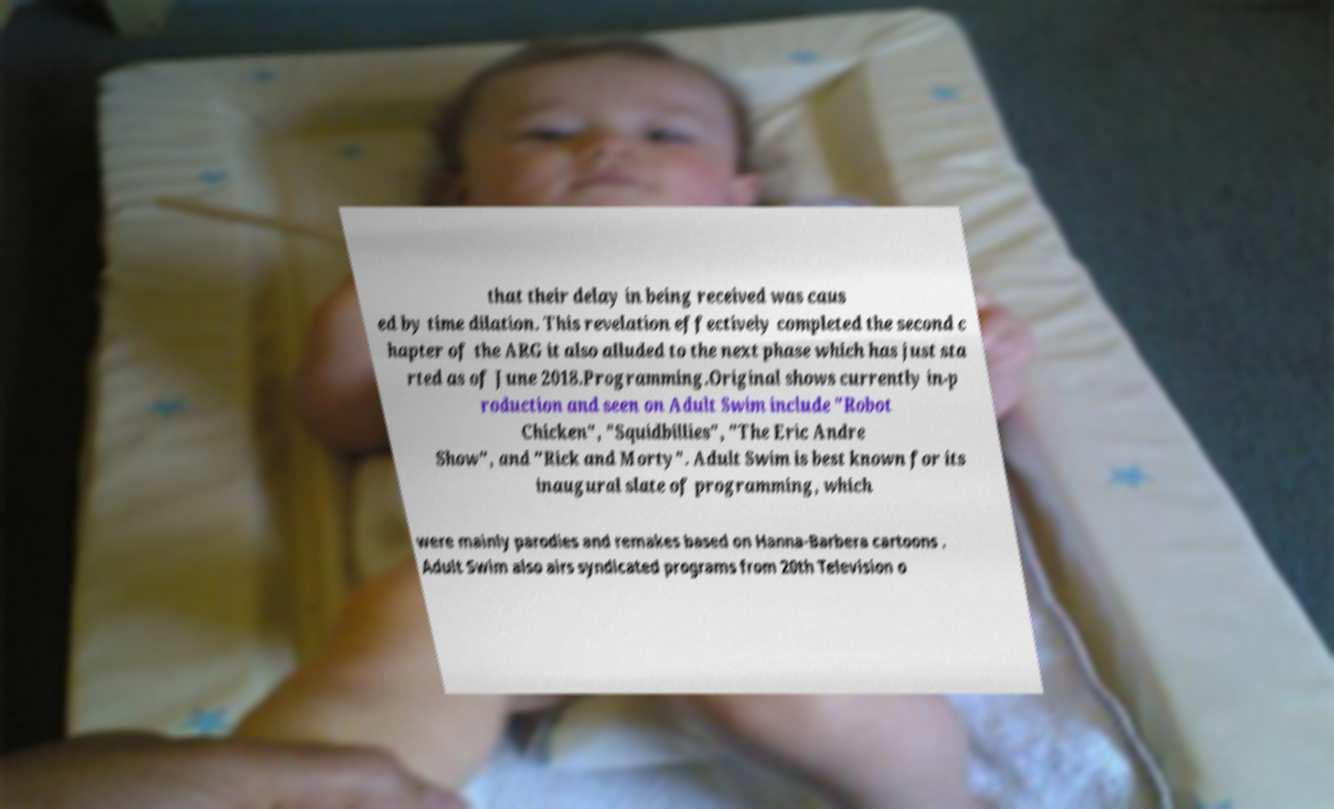Could you extract and type out the text from this image? that their delay in being received was caus ed by time dilation. This revelation effectively completed the second c hapter of the ARG it also alluded to the next phase which has just sta rted as of June 2018.Programming.Original shows currently in-p roduction and seen on Adult Swim include "Robot Chicken", "Squidbillies", "The Eric Andre Show", and "Rick and Morty". Adult Swim is best known for its inaugural slate of programming, which were mainly parodies and remakes based on Hanna-Barbera cartoons . Adult Swim also airs syndicated programs from 20th Television o 